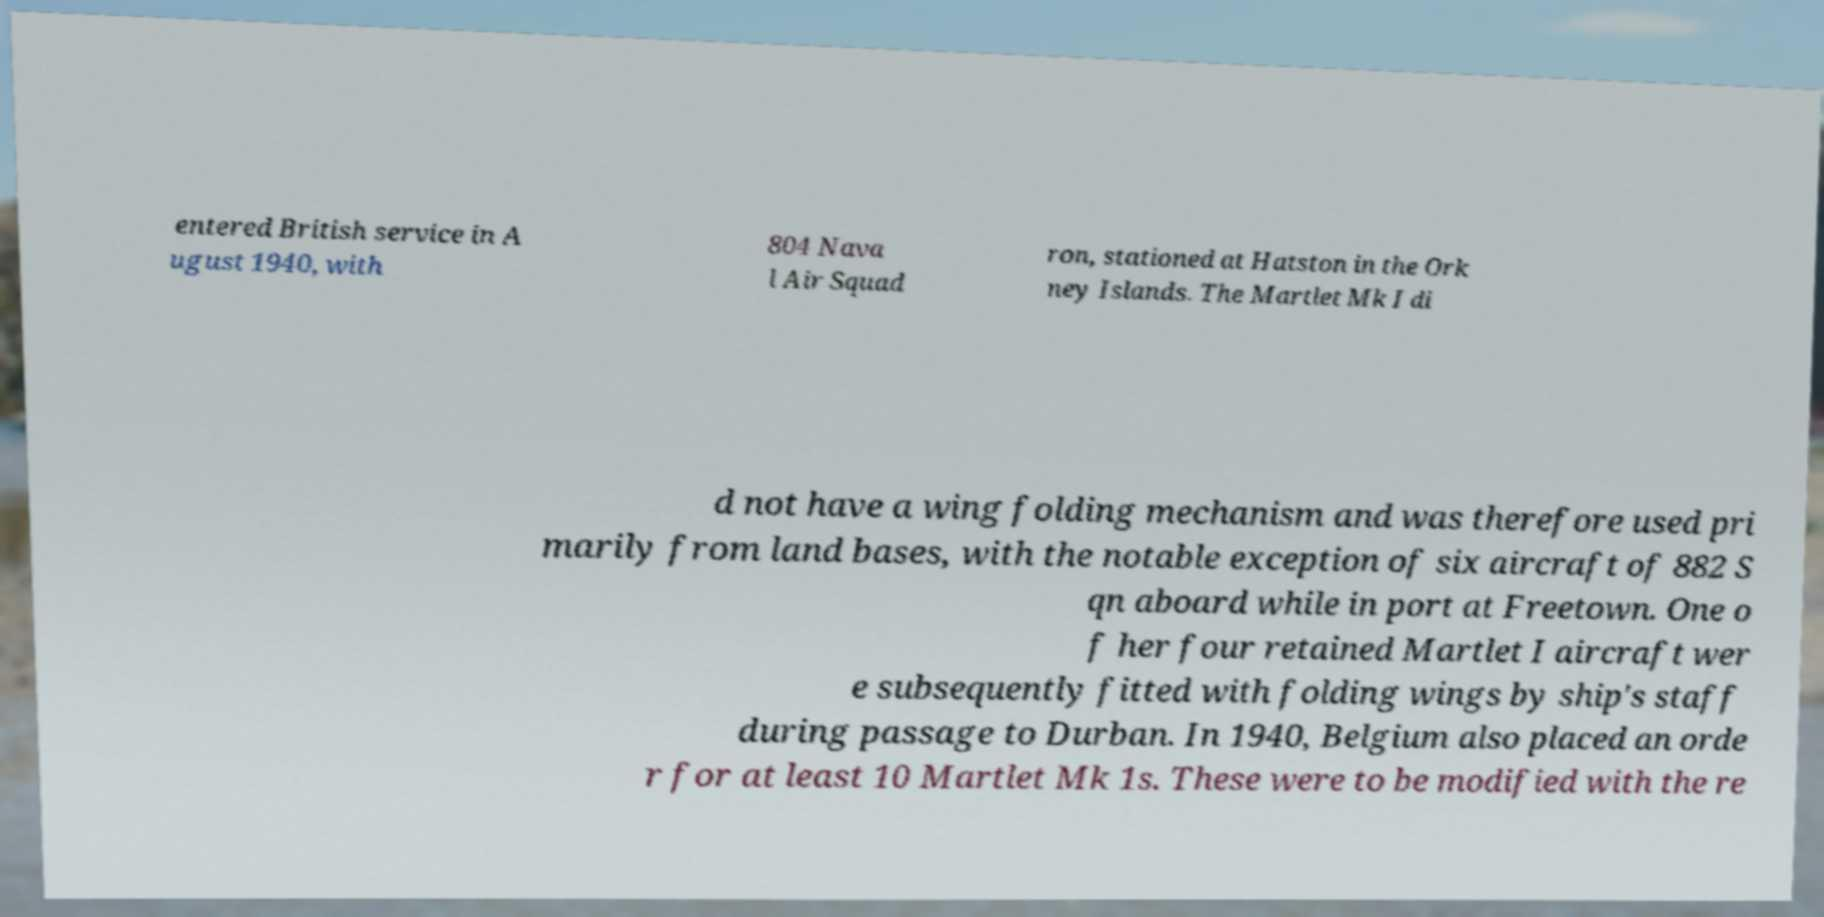For documentation purposes, I need the text within this image transcribed. Could you provide that? entered British service in A ugust 1940, with 804 Nava l Air Squad ron, stationed at Hatston in the Ork ney Islands. The Martlet Mk I di d not have a wing folding mechanism and was therefore used pri marily from land bases, with the notable exception of six aircraft of 882 S qn aboard while in port at Freetown. One o f her four retained Martlet I aircraft wer e subsequently fitted with folding wings by ship's staff during passage to Durban. In 1940, Belgium also placed an orde r for at least 10 Martlet Mk 1s. These were to be modified with the re 